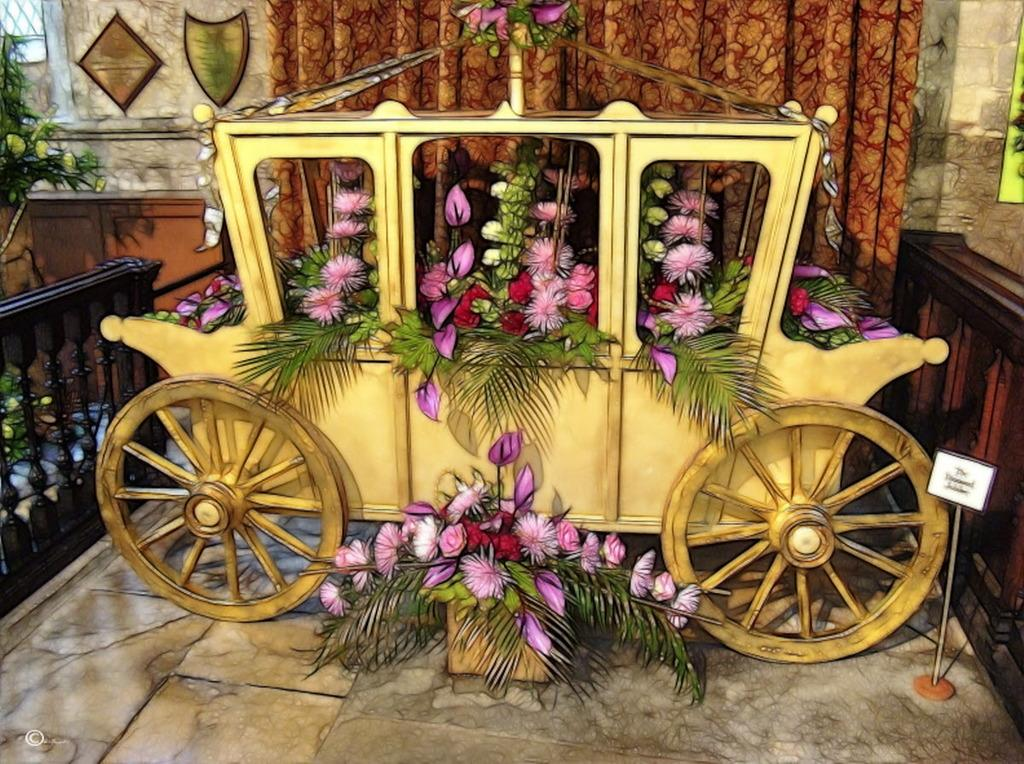What is the main subject of the image? The image contains an art piece. What does the art piece depict? The art piece depicts a vehicle. Where is the vehicle located in relation to the curtain? The vehicle is beside a curtain. What is the design of the curtain? The curtain is filled with flowers. What other floral element can be seen in the image? There is a flowers pot at the bottom of the image. How many cats can be seen playing on top of the vehicle in the image? There are no cats present in the image, and the vehicle is not depicted as having any cats on top of it. 